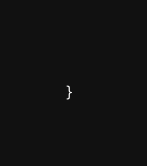<code> <loc_0><loc_0><loc_500><loc_500><_TypeScript_>	
}</code> 